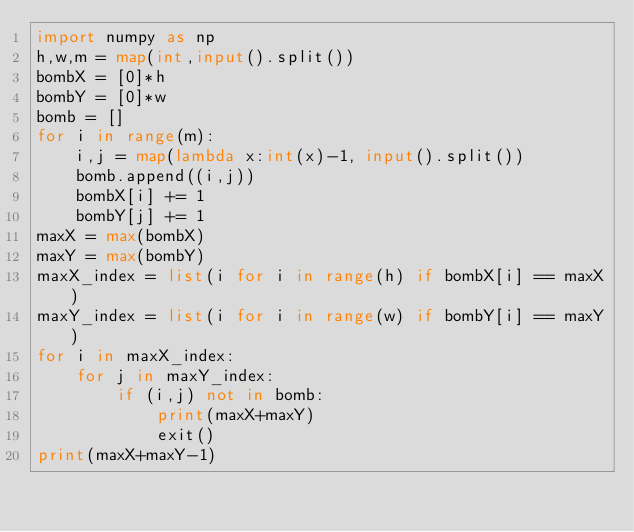<code> <loc_0><loc_0><loc_500><loc_500><_Python_>import numpy as np
h,w,m = map(int,input().split())
bombX = [0]*h
bombY = [0]*w
bomb = []
for i in range(m):
    i,j = map(lambda x:int(x)-1, input().split())
    bomb.append((i,j))
    bombX[i] += 1
    bombY[j] += 1
maxX = max(bombX)
maxY = max(bombY)
maxX_index = list(i for i in range(h) if bombX[i] == maxX)
maxY_index = list(i for i in range(w) if bombY[i] == maxY)
for i in maxX_index:
    for j in maxY_index:
        if (i,j) not in bomb:
            print(maxX+maxY)
            exit()
print(maxX+maxY-1)
</code> 